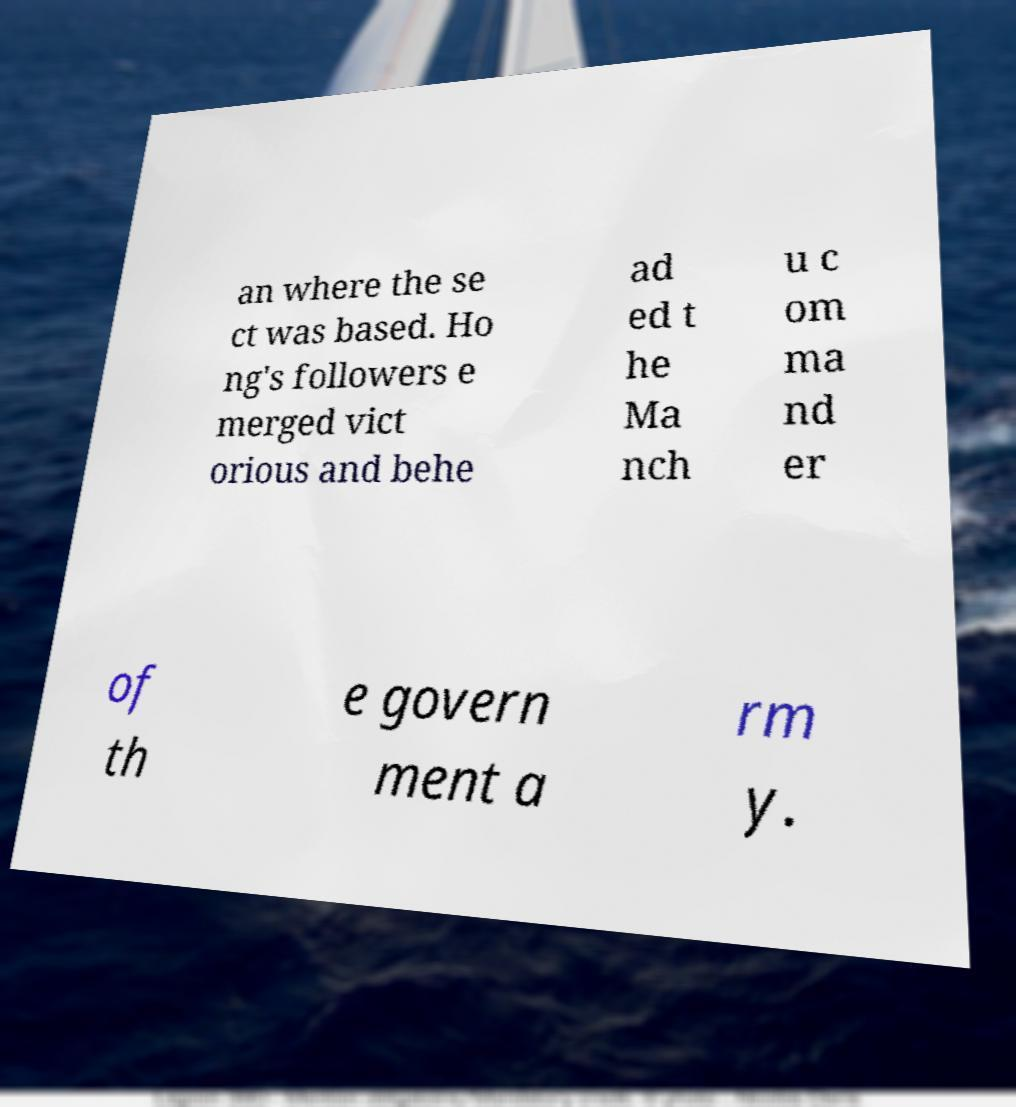For documentation purposes, I need the text within this image transcribed. Could you provide that? an where the se ct was based. Ho ng's followers e merged vict orious and behe ad ed t he Ma nch u c om ma nd er of th e govern ment a rm y. 